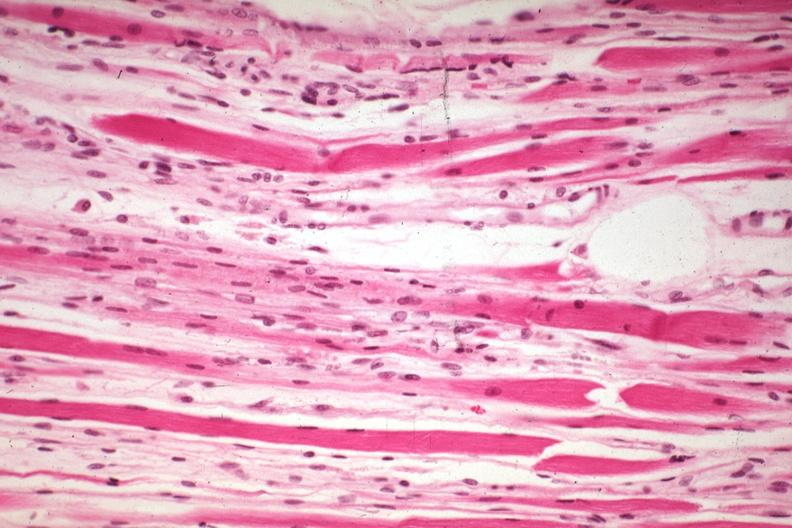does this image show high excellent steroid induced atrophy?
Answer the question using a single word or phrase. Yes 